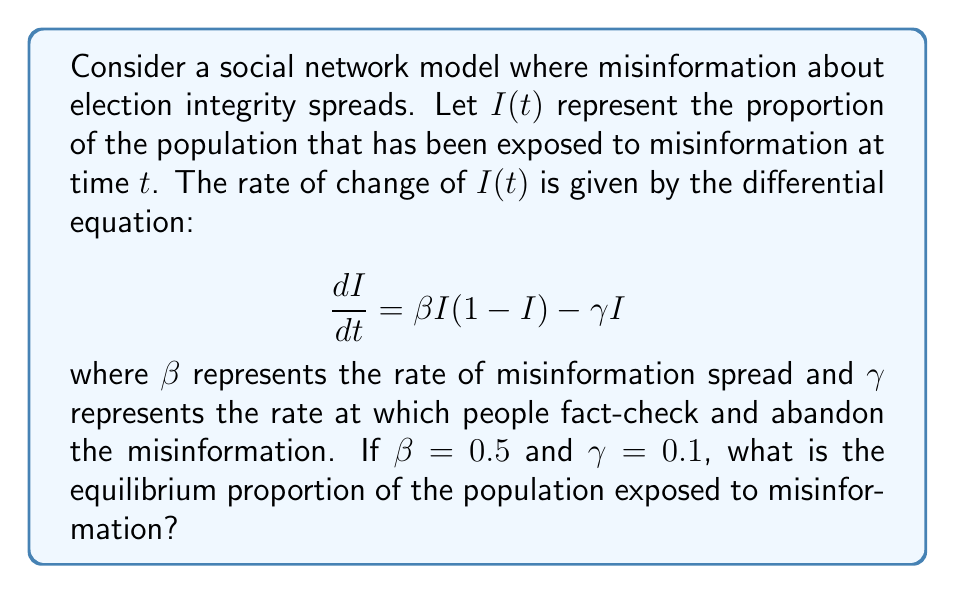Solve this math problem. To find the equilibrium proportion, we need to solve for $I$ when $\frac{dI}{dt} = 0$:

1) Set the differential equation to zero:
   $$0 = \beta I(1-I) - \gamma I$$

2) Substitute the given values $\beta = 0.5$ and $\gamma = 0.1$:
   $$0 = 0.5I(1-I) - 0.1I$$

3) Factor out $I$:
   $$0 = I(0.5(1-I) - 0.1)$$

4) For this to be true, either $I = 0$ or the term in parentheses equals zero. Let's solve the latter:
   $$0.5(1-I) - 0.1 = 0$$

5) Solve for $I$:
   $$0.5 - 0.5I - 0.1 = 0$$
   $$0.4 - 0.5I = 0$$
   $$0.4 = 0.5I$$
   $$I = \frac{0.4}{0.5} = 0.8$$

6) Check that this solution is between 0 and 1, as required for a proportion.

Therefore, the non-zero equilibrium occurs when 80% of the population has been exposed to misinformation.
Answer: $I = 0.8$ or $80\%$ 